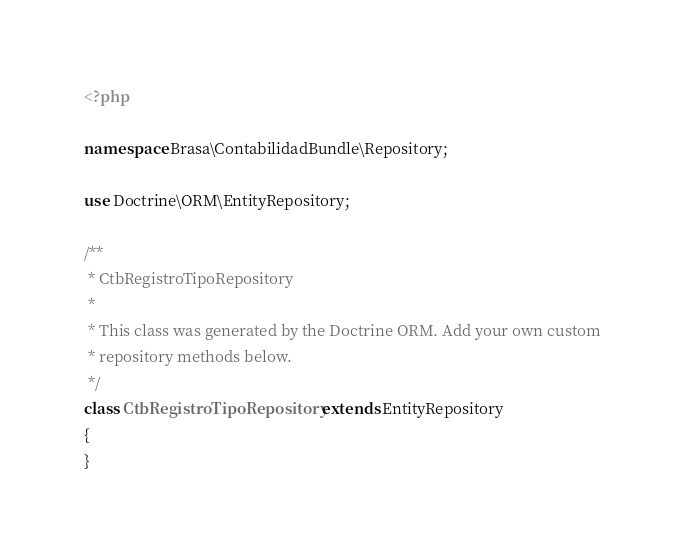<code> <loc_0><loc_0><loc_500><loc_500><_PHP_><?php

namespace Brasa\ContabilidadBundle\Repository;

use Doctrine\ORM\EntityRepository;

/**
 * CtbRegistroTipoRepository
 *
 * This class was generated by the Doctrine ORM. Add your own custom
 * repository methods below.
 */
class CtbRegistroTipoRepository extends EntityRepository
{
}</code> 